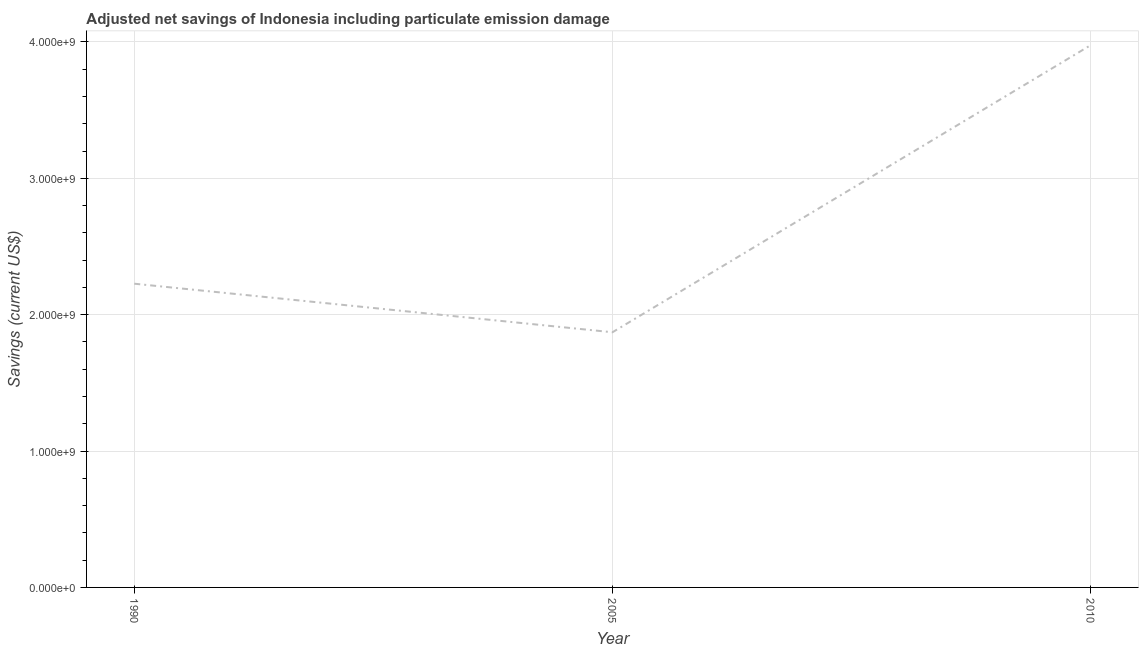What is the adjusted net savings in 2010?
Provide a short and direct response. 3.98e+09. Across all years, what is the maximum adjusted net savings?
Make the answer very short. 3.98e+09. Across all years, what is the minimum adjusted net savings?
Offer a very short reply. 1.87e+09. In which year was the adjusted net savings maximum?
Give a very brief answer. 2010. What is the sum of the adjusted net savings?
Offer a terse response. 8.07e+09. What is the difference between the adjusted net savings in 1990 and 2010?
Provide a short and direct response. -1.75e+09. What is the average adjusted net savings per year?
Provide a short and direct response. 2.69e+09. What is the median adjusted net savings?
Your answer should be very brief. 2.23e+09. Do a majority of the years between 1990 and 2005 (inclusive) have adjusted net savings greater than 3000000000 US$?
Give a very brief answer. No. What is the ratio of the adjusted net savings in 2005 to that in 2010?
Keep it short and to the point. 0.47. Is the adjusted net savings in 2005 less than that in 2010?
Your response must be concise. Yes. What is the difference between the highest and the second highest adjusted net savings?
Offer a terse response. 1.75e+09. What is the difference between the highest and the lowest adjusted net savings?
Offer a very short reply. 2.11e+09. Does the adjusted net savings monotonically increase over the years?
Your answer should be very brief. No. How many lines are there?
Keep it short and to the point. 1. How many years are there in the graph?
Provide a succinct answer. 3. What is the difference between two consecutive major ticks on the Y-axis?
Provide a short and direct response. 1.00e+09. What is the title of the graph?
Your answer should be compact. Adjusted net savings of Indonesia including particulate emission damage. What is the label or title of the Y-axis?
Offer a very short reply. Savings (current US$). What is the Savings (current US$) of 1990?
Your answer should be compact. 2.23e+09. What is the Savings (current US$) in 2005?
Provide a short and direct response. 1.87e+09. What is the Savings (current US$) of 2010?
Give a very brief answer. 3.98e+09. What is the difference between the Savings (current US$) in 1990 and 2005?
Keep it short and to the point. 3.56e+08. What is the difference between the Savings (current US$) in 1990 and 2010?
Make the answer very short. -1.75e+09. What is the difference between the Savings (current US$) in 2005 and 2010?
Ensure brevity in your answer.  -2.11e+09. What is the ratio of the Savings (current US$) in 1990 to that in 2005?
Offer a very short reply. 1.19. What is the ratio of the Savings (current US$) in 1990 to that in 2010?
Your answer should be very brief. 0.56. What is the ratio of the Savings (current US$) in 2005 to that in 2010?
Your answer should be very brief. 0.47. 